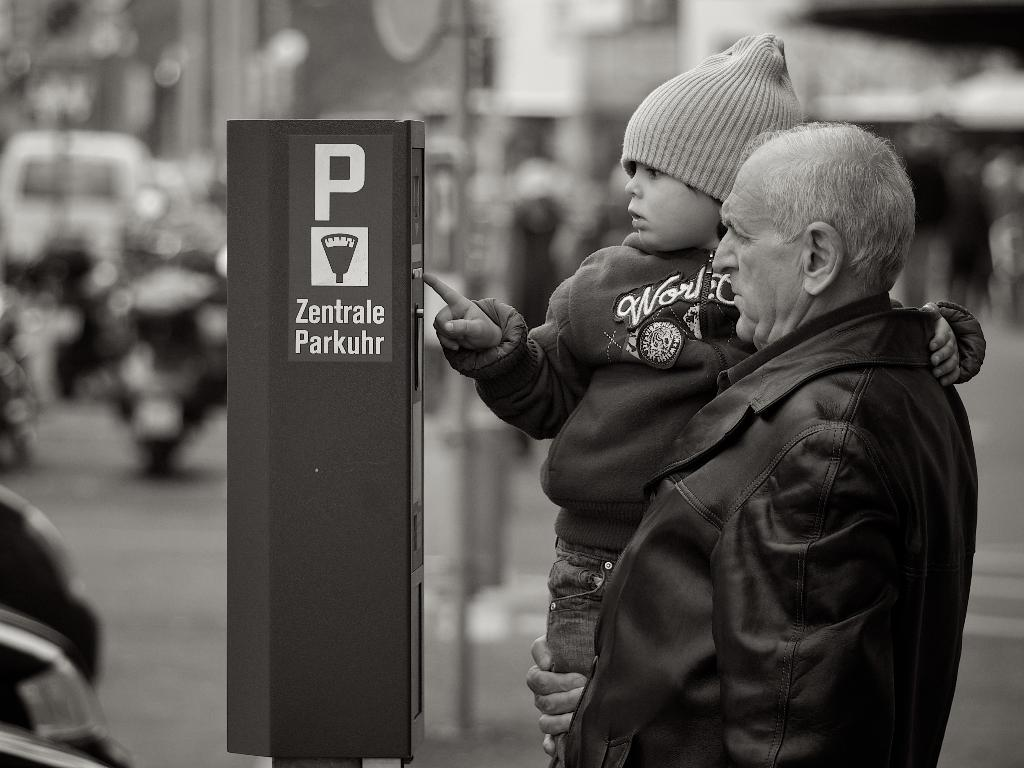<image>
Share a concise interpretation of the image provided. a boy looking at something next to the letter P on a sign 